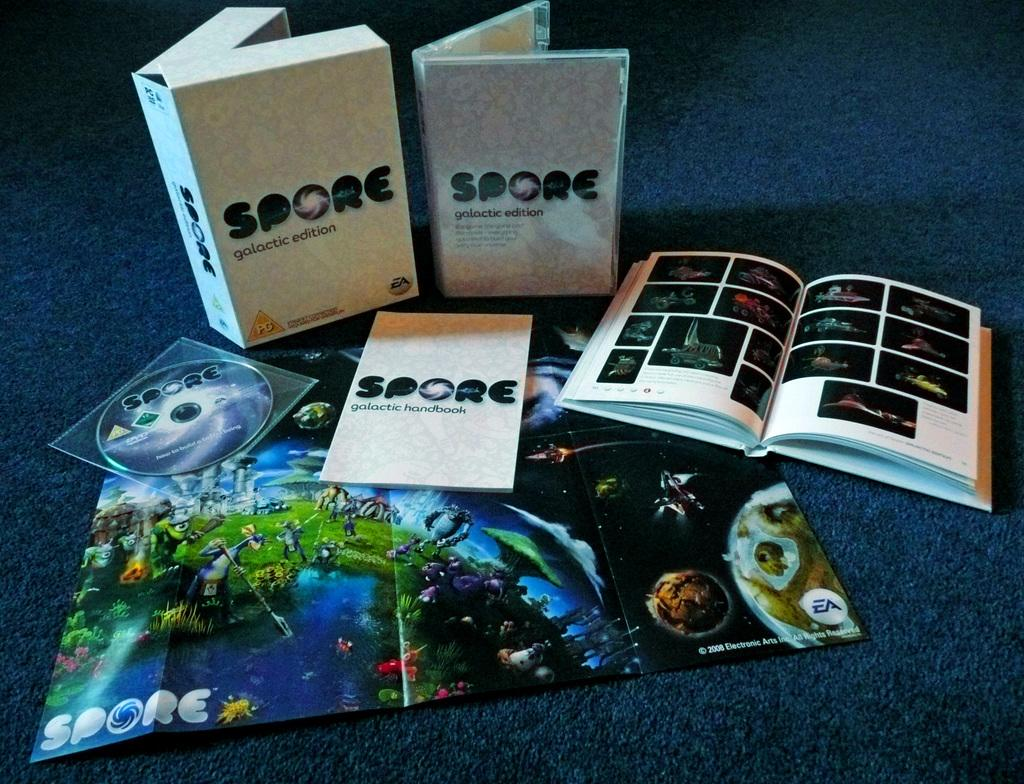<image>
Render a clear and concise summary of the photo. spore has books and posters as well as DVD's to teach their material 